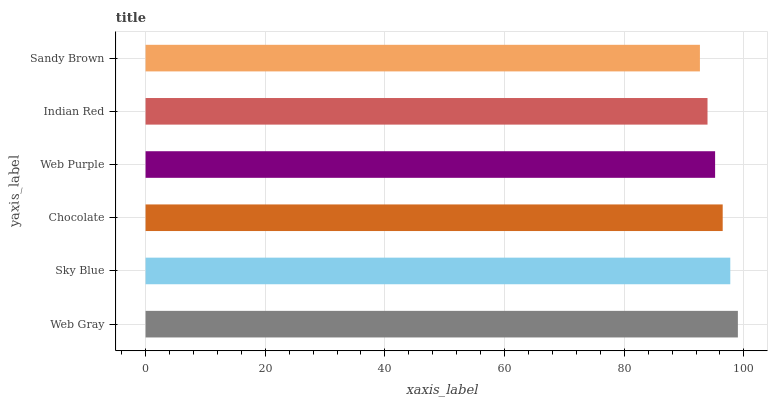Is Sandy Brown the minimum?
Answer yes or no. Yes. Is Web Gray the maximum?
Answer yes or no. Yes. Is Sky Blue the minimum?
Answer yes or no. No. Is Sky Blue the maximum?
Answer yes or no. No. Is Web Gray greater than Sky Blue?
Answer yes or no. Yes. Is Sky Blue less than Web Gray?
Answer yes or no. Yes. Is Sky Blue greater than Web Gray?
Answer yes or no. No. Is Web Gray less than Sky Blue?
Answer yes or no. No. Is Chocolate the high median?
Answer yes or no. Yes. Is Web Purple the low median?
Answer yes or no. Yes. Is Sandy Brown the high median?
Answer yes or no. No. Is Sandy Brown the low median?
Answer yes or no. No. 